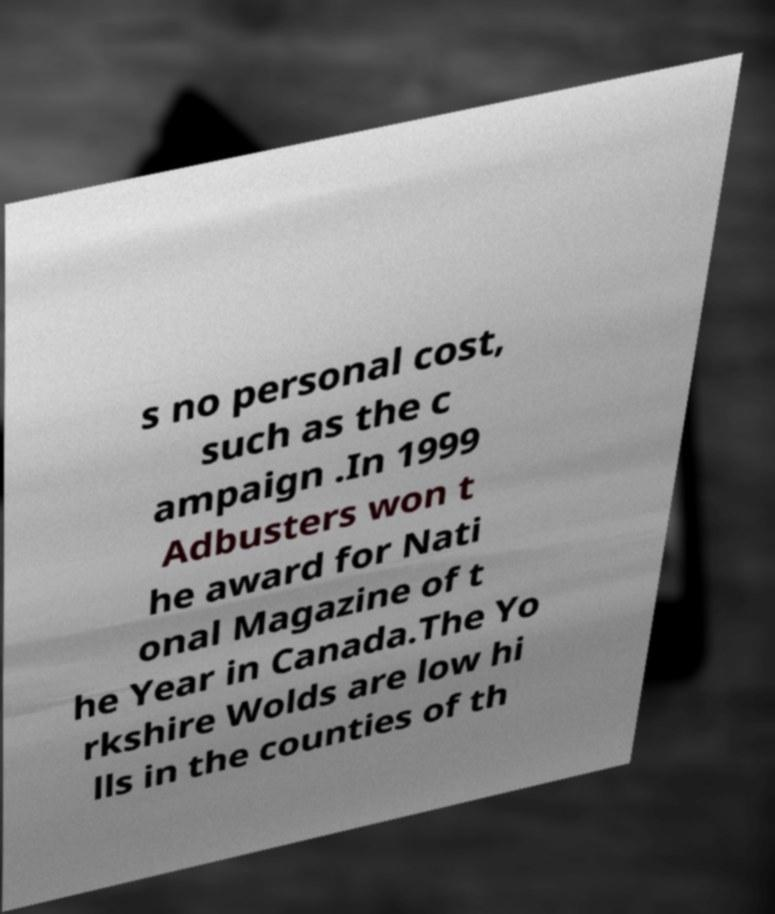Can you read and provide the text displayed in the image?This photo seems to have some interesting text. Can you extract and type it out for me? s no personal cost, such as the c ampaign .In 1999 Adbusters won t he award for Nati onal Magazine of t he Year in Canada.The Yo rkshire Wolds are low hi lls in the counties of th 